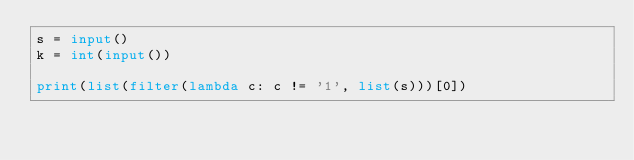Convert code to text. <code><loc_0><loc_0><loc_500><loc_500><_Python_>s = input()
k = int(input())

print(list(filter(lambda c: c != '1', list(s)))[0])</code> 